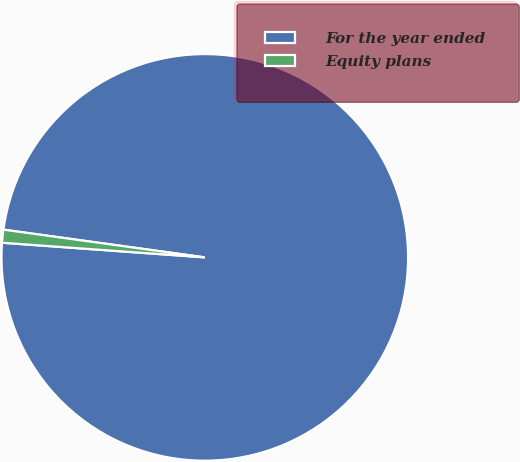Convert chart. <chart><loc_0><loc_0><loc_500><loc_500><pie_chart><fcel>For the year ended<fcel>Equity plans<nl><fcel>98.97%<fcel>1.03%<nl></chart> 